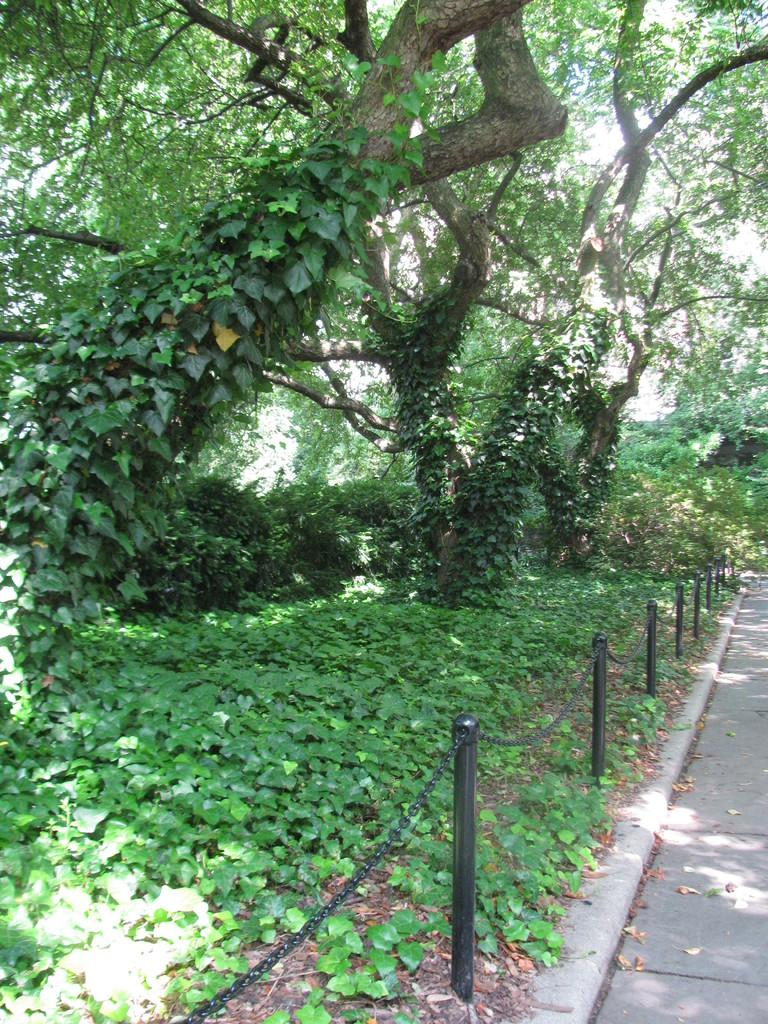What type of vegetation can be seen in the image? There are trees in the image. What objects are made of iron and have chains attached to them? There are black color iron poles with chains in the image. Where are the iron poles located in the image? The iron poles are in the middle of the image. What can be seen on the right side of the image? There is a road on the right side of the image. How many spiders are crawling on the iron poles in the image? There are no spiders present in the image; it only features iron poles with chains. What type of cup is being used to hold the chains on the iron poles? There is no cup present in the image; the chains are attached directly to the iron poles. 